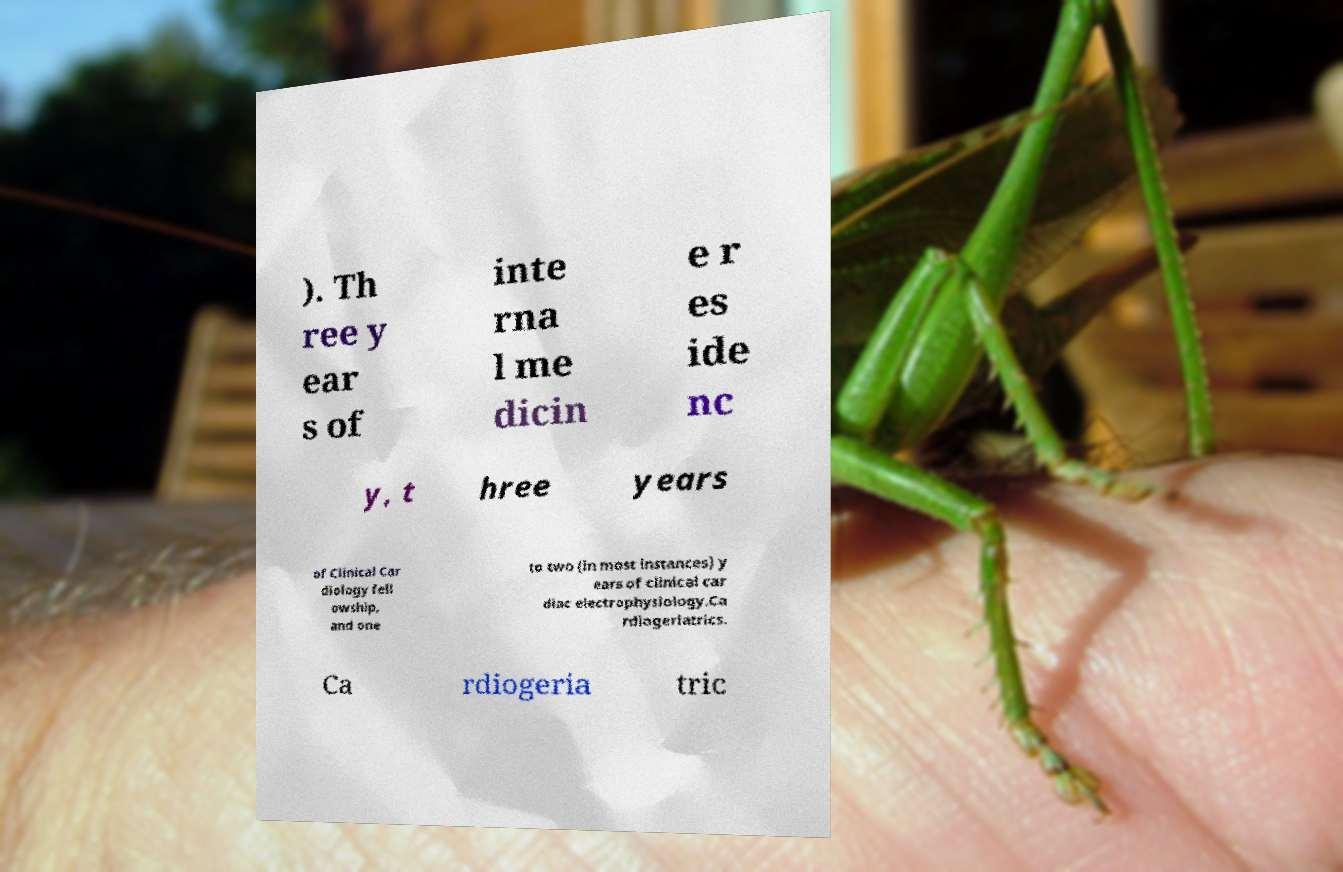For documentation purposes, I need the text within this image transcribed. Could you provide that? ). Th ree y ear s of inte rna l me dicin e r es ide nc y, t hree years of Clinical Car diology fell owship, and one to two (in most instances) y ears of clinical car diac electrophysiology.Ca rdiogeriatrics. Ca rdiogeria tric 